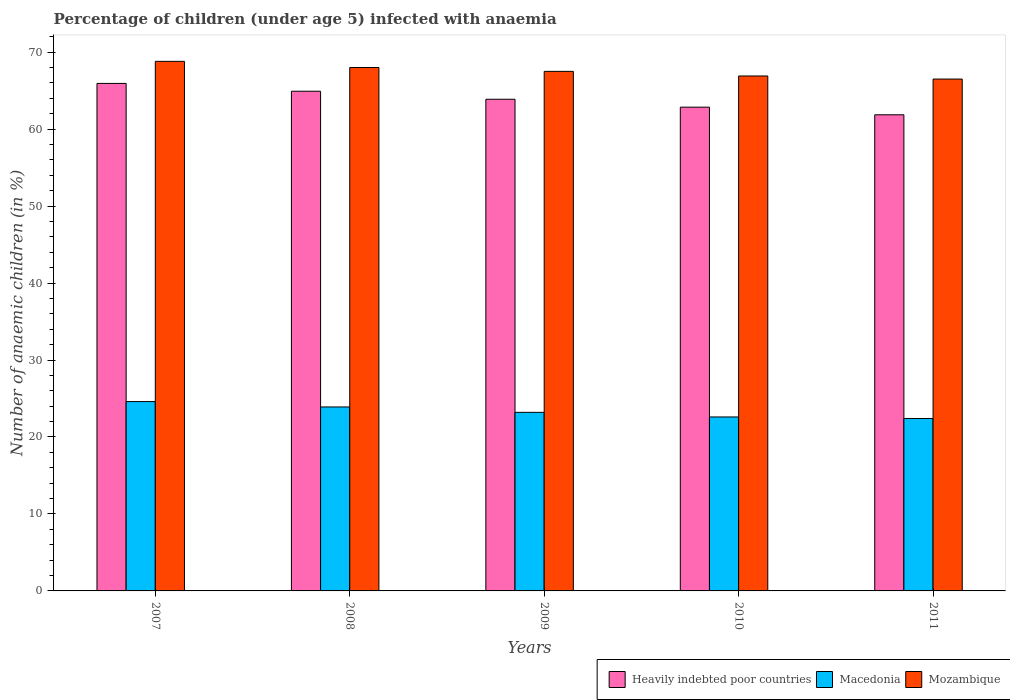How many different coloured bars are there?
Your answer should be very brief. 3. Are the number of bars per tick equal to the number of legend labels?
Give a very brief answer. Yes. How many bars are there on the 1st tick from the left?
Your answer should be very brief. 3. What is the percentage of children infected with anaemia in in Macedonia in 2010?
Offer a very short reply. 22.6. Across all years, what is the maximum percentage of children infected with anaemia in in Macedonia?
Offer a terse response. 24.6. Across all years, what is the minimum percentage of children infected with anaemia in in Mozambique?
Your answer should be very brief. 66.5. In which year was the percentage of children infected with anaemia in in Mozambique maximum?
Provide a succinct answer. 2007. In which year was the percentage of children infected with anaemia in in Macedonia minimum?
Offer a terse response. 2011. What is the total percentage of children infected with anaemia in in Macedonia in the graph?
Provide a succinct answer. 116.7. What is the difference between the percentage of children infected with anaemia in in Heavily indebted poor countries in 2007 and that in 2010?
Give a very brief answer. 3.09. What is the difference between the percentage of children infected with anaemia in in Mozambique in 2008 and the percentage of children infected with anaemia in in Macedonia in 2010?
Offer a terse response. 45.4. What is the average percentage of children infected with anaemia in in Mozambique per year?
Your answer should be very brief. 67.54. In the year 2009, what is the difference between the percentage of children infected with anaemia in in Heavily indebted poor countries and percentage of children infected with anaemia in in Mozambique?
Make the answer very short. -3.62. In how many years, is the percentage of children infected with anaemia in in Heavily indebted poor countries greater than 60 %?
Your answer should be very brief. 5. What is the ratio of the percentage of children infected with anaemia in in Macedonia in 2008 to that in 2011?
Your answer should be compact. 1.07. Is the percentage of children infected with anaemia in in Mozambique in 2009 less than that in 2010?
Give a very brief answer. No. Is the difference between the percentage of children infected with anaemia in in Heavily indebted poor countries in 2008 and 2011 greater than the difference between the percentage of children infected with anaemia in in Mozambique in 2008 and 2011?
Provide a succinct answer. Yes. What is the difference between the highest and the second highest percentage of children infected with anaemia in in Heavily indebted poor countries?
Ensure brevity in your answer.  1.02. What is the difference between the highest and the lowest percentage of children infected with anaemia in in Heavily indebted poor countries?
Provide a succinct answer. 4.08. In how many years, is the percentage of children infected with anaemia in in Macedonia greater than the average percentage of children infected with anaemia in in Macedonia taken over all years?
Provide a short and direct response. 2. Is the sum of the percentage of children infected with anaemia in in Heavily indebted poor countries in 2007 and 2010 greater than the maximum percentage of children infected with anaemia in in Mozambique across all years?
Offer a terse response. Yes. What does the 2nd bar from the left in 2011 represents?
Offer a very short reply. Macedonia. What does the 2nd bar from the right in 2008 represents?
Offer a terse response. Macedonia. What is the difference between two consecutive major ticks on the Y-axis?
Offer a very short reply. 10. Does the graph contain any zero values?
Your answer should be very brief. No. Where does the legend appear in the graph?
Your answer should be compact. Bottom right. What is the title of the graph?
Make the answer very short. Percentage of children (under age 5) infected with anaemia. Does "Bosnia and Herzegovina" appear as one of the legend labels in the graph?
Ensure brevity in your answer.  No. What is the label or title of the Y-axis?
Offer a terse response. Number of anaemic children (in %). What is the Number of anaemic children (in %) of Heavily indebted poor countries in 2007?
Keep it short and to the point. 65.93. What is the Number of anaemic children (in %) in Macedonia in 2007?
Your answer should be very brief. 24.6. What is the Number of anaemic children (in %) of Mozambique in 2007?
Provide a succinct answer. 68.8. What is the Number of anaemic children (in %) of Heavily indebted poor countries in 2008?
Offer a terse response. 64.92. What is the Number of anaemic children (in %) in Macedonia in 2008?
Your response must be concise. 23.9. What is the Number of anaemic children (in %) in Mozambique in 2008?
Offer a terse response. 68. What is the Number of anaemic children (in %) in Heavily indebted poor countries in 2009?
Provide a succinct answer. 63.88. What is the Number of anaemic children (in %) in Macedonia in 2009?
Your answer should be compact. 23.2. What is the Number of anaemic children (in %) of Mozambique in 2009?
Ensure brevity in your answer.  67.5. What is the Number of anaemic children (in %) in Heavily indebted poor countries in 2010?
Ensure brevity in your answer.  62.85. What is the Number of anaemic children (in %) in Macedonia in 2010?
Ensure brevity in your answer.  22.6. What is the Number of anaemic children (in %) of Mozambique in 2010?
Make the answer very short. 66.9. What is the Number of anaemic children (in %) in Heavily indebted poor countries in 2011?
Provide a succinct answer. 61.86. What is the Number of anaemic children (in %) in Macedonia in 2011?
Make the answer very short. 22.4. What is the Number of anaemic children (in %) in Mozambique in 2011?
Ensure brevity in your answer.  66.5. Across all years, what is the maximum Number of anaemic children (in %) of Heavily indebted poor countries?
Keep it short and to the point. 65.93. Across all years, what is the maximum Number of anaemic children (in %) of Macedonia?
Give a very brief answer. 24.6. Across all years, what is the maximum Number of anaemic children (in %) in Mozambique?
Give a very brief answer. 68.8. Across all years, what is the minimum Number of anaemic children (in %) in Heavily indebted poor countries?
Your response must be concise. 61.86. Across all years, what is the minimum Number of anaemic children (in %) of Macedonia?
Make the answer very short. 22.4. Across all years, what is the minimum Number of anaemic children (in %) in Mozambique?
Your answer should be compact. 66.5. What is the total Number of anaemic children (in %) in Heavily indebted poor countries in the graph?
Provide a short and direct response. 319.43. What is the total Number of anaemic children (in %) of Macedonia in the graph?
Your answer should be very brief. 116.7. What is the total Number of anaemic children (in %) in Mozambique in the graph?
Provide a succinct answer. 337.7. What is the difference between the Number of anaemic children (in %) of Heavily indebted poor countries in 2007 and that in 2008?
Your answer should be compact. 1.02. What is the difference between the Number of anaemic children (in %) of Macedonia in 2007 and that in 2008?
Provide a short and direct response. 0.7. What is the difference between the Number of anaemic children (in %) of Heavily indebted poor countries in 2007 and that in 2009?
Offer a very short reply. 2.06. What is the difference between the Number of anaemic children (in %) in Macedonia in 2007 and that in 2009?
Make the answer very short. 1.4. What is the difference between the Number of anaemic children (in %) in Mozambique in 2007 and that in 2009?
Give a very brief answer. 1.3. What is the difference between the Number of anaemic children (in %) in Heavily indebted poor countries in 2007 and that in 2010?
Your answer should be very brief. 3.09. What is the difference between the Number of anaemic children (in %) in Heavily indebted poor countries in 2007 and that in 2011?
Ensure brevity in your answer.  4.08. What is the difference between the Number of anaemic children (in %) of Mozambique in 2007 and that in 2011?
Provide a short and direct response. 2.3. What is the difference between the Number of anaemic children (in %) of Heavily indebted poor countries in 2008 and that in 2009?
Keep it short and to the point. 1.04. What is the difference between the Number of anaemic children (in %) of Macedonia in 2008 and that in 2009?
Make the answer very short. 0.7. What is the difference between the Number of anaemic children (in %) of Heavily indebted poor countries in 2008 and that in 2010?
Make the answer very short. 2.07. What is the difference between the Number of anaemic children (in %) in Macedonia in 2008 and that in 2010?
Make the answer very short. 1.3. What is the difference between the Number of anaemic children (in %) in Mozambique in 2008 and that in 2010?
Give a very brief answer. 1.1. What is the difference between the Number of anaemic children (in %) in Heavily indebted poor countries in 2008 and that in 2011?
Provide a short and direct response. 3.06. What is the difference between the Number of anaemic children (in %) of Macedonia in 2008 and that in 2011?
Offer a very short reply. 1.5. What is the difference between the Number of anaemic children (in %) of Heavily indebted poor countries in 2009 and that in 2010?
Your response must be concise. 1.03. What is the difference between the Number of anaemic children (in %) in Heavily indebted poor countries in 2009 and that in 2011?
Provide a succinct answer. 2.02. What is the difference between the Number of anaemic children (in %) of Macedonia in 2009 and that in 2011?
Your answer should be compact. 0.8. What is the difference between the Number of anaemic children (in %) of Heavily indebted poor countries in 2010 and that in 2011?
Your response must be concise. 0.99. What is the difference between the Number of anaemic children (in %) in Heavily indebted poor countries in 2007 and the Number of anaemic children (in %) in Macedonia in 2008?
Give a very brief answer. 42.03. What is the difference between the Number of anaemic children (in %) of Heavily indebted poor countries in 2007 and the Number of anaemic children (in %) of Mozambique in 2008?
Provide a short and direct response. -2.07. What is the difference between the Number of anaemic children (in %) of Macedonia in 2007 and the Number of anaemic children (in %) of Mozambique in 2008?
Offer a very short reply. -43.4. What is the difference between the Number of anaemic children (in %) of Heavily indebted poor countries in 2007 and the Number of anaemic children (in %) of Macedonia in 2009?
Keep it short and to the point. 42.73. What is the difference between the Number of anaemic children (in %) in Heavily indebted poor countries in 2007 and the Number of anaemic children (in %) in Mozambique in 2009?
Keep it short and to the point. -1.57. What is the difference between the Number of anaemic children (in %) in Macedonia in 2007 and the Number of anaemic children (in %) in Mozambique in 2009?
Your answer should be very brief. -42.9. What is the difference between the Number of anaemic children (in %) in Heavily indebted poor countries in 2007 and the Number of anaemic children (in %) in Macedonia in 2010?
Your answer should be compact. 43.33. What is the difference between the Number of anaemic children (in %) in Heavily indebted poor countries in 2007 and the Number of anaemic children (in %) in Mozambique in 2010?
Give a very brief answer. -0.97. What is the difference between the Number of anaemic children (in %) of Macedonia in 2007 and the Number of anaemic children (in %) of Mozambique in 2010?
Keep it short and to the point. -42.3. What is the difference between the Number of anaemic children (in %) of Heavily indebted poor countries in 2007 and the Number of anaemic children (in %) of Macedonia in 2011?
Your response must be concise. 43.53. What is the difference between the Number of anaemic children (in %) of Heavily indebted poor countries in 2007 and the Number of anaemic children (in %) of Mozambique in 2011?
Your response must be concise. -0.57. What is the difference between the Number of anaemic children (in %) of Macedonia in 2007 and the Number of anaemic children (in %) of Mozambique in 2011?
Keep it short and to the point. -41.9. What is the difference between the Number of anaemic children (in %) of Heavily indebted poor countries in 2008 and the Number of anaemic children (in %) of Macedonia in 2009?
Offer a very short reply. 41.72. What is the difference between the Number of anaemic children (in %) in Heavily indebted poor countries in 2008 and the Number of anaemic children (in %) in Mozambique in 2009?
Keep it short and to the point. -2.58. What is the difference between the Number of anaemic children (in %) in Macedonia in 2008 and the Number of anaemic children (in %) in Mozambique in 2009?
Make the answer very short. -43.6. What is the difference between the Number of anaemic children (in %) in Heavily indebted poor countries in 2008 and the Number of anaemic children (in %) in Macedonia in 2010?
Your response must be concise. 42.32. What is the difference between the Number of anaemic children (in %) in Heavily indebted poor countries in 2008 and the Number of anaemic children (in %) in Mozambique in 2010?
Offer a very short reply. -1.98. What is the difference between the Number of anaemic children (in %) of Macedonia in 2008 and the Number of anaemic children (in %) of Mozambique in 2010?
Provide a succinct answer. -43. What is the difference between the Number of anaemic children (in %) of Heavily indebted poor countries in 2008 and the Number of anaemic children (in %) of Macedonia in 2011?
Offer a terse response. 42.52. What is the difference between the Number of anaemic children (in %) of Heavily indebted poor countries in 2008 and the Number of anaemic children (in %) of Mozambique in 2011?
Your answer should be very brief. -1.58. What is the difference between the Number of anaemic children (in %) of Macedonia in 2008 and the Number of anaemic children (in %) of Mozambique in 2011?
Ensure brevity in your answer.  -42.6. What is the difference between the Number of anaemic children (in %) of Heavily indebted poor countries in 2009 and the Number of anaemic children (in %) of Macedonia in 2010?
Your answer should be compact. 41.28. What is the difference between the Number of anaemic children (in %) in Heavily indebted poor countries in 2009 and the Number of anaemic children (in %) in Mozambique in 2010?
Your response must be concise. -3.02. What is the difference between the Number of anaemic children (in %) of Macedonia in 2009 and the Number of anaemic children (in %) of Mozambique in 2010?
Provide a succinct answer. -43.7. What is the difference between the Number of anaemic children (in %) in Heavily indebted poor countries in 2009 and the Number of anaemic children (in %) in Macedonia in 2011?
Your answer should be compact. 41.48. What is the difference between the Number of anaemic children (in %) of Heavily indebted poor countries in 2009 and the Number of anaemic children (in %) of Mozambique in 2011?
Provide a short and direct response. -2.62. What is the difference between the Number of anaemic children (in %) in Macedonia in 2009 and the Number of anaemic children (in %) in Mozambique in 2011?
Offer a terse response. -43.3. What is the difference between the Number of anaemic children (in %) of Heavily indebted poor countries in 2010 and the Number of anaemic children (in %) of Macedonia in 2011?
Offer a terse response. 40.45. What is the difference between the Number of anaemic children (in %) in Heavily indebted poor countries in 2010 and the Number of anaemic children (in %) in Mozambique in 2011?
Make the answer very short. -3.65. What is the difference between the Number of anaemic children (in %) of Macedonia in 2010 and the Number of anaemic children (in %) of Mozambique in 2011?
Provide a succinct answer. -43.9. What is the average Number of anaemic children (in %) in Heavily indebted poor countries per year?
Offer a very short reply. 63.89. What is the average Number of anaemic children (in %) of Macedonia per year?
Your response must be concise. 23.34. What is the average Number of anaemic children (in %) of Mozambique per year?
Your answer should be compact. 67.54. In the year 2007, what is the difference between the Number of anaemic children (in %) of Heavily indebted poor countries and Number of anaemic children (in %) of Macedonia?
Ensure brevity in your answer.  41.33. In the year 2007, what is the difference between the Number of anaemic children (in %) in Heavily indebted poor countries and Number of anaemic children (in %) in Mozambique?
Make the answer very short. -2.87. In the year 2007, what is the difference between the Number of anaemic children (in %) in Macedonia and Number of anaemic children (in %) in Mozambique?
Make the answer very short. -44.2. In the year 2008, what is the difference between the Number of anaemic children (in %) in Heavily indebted poor countries and Number of anaemic children (in %) in Macedonia?
Your answer should be very brief. 41.02. In the year 2008, what is the difference between the Number of anaemic children (in %) of Heavily indebted poor countries and Number of anaemic children (in %) of Mozambique?
Make the answer very short. -3.08. In the year 2008, what is the difference between the Number of anaemic children (in %) of Macedonia and Number of anaemic children (in %) of Mozambique?
Your answer should be very brief. -44.1. In the year 2009, what is the difference between the Number of anaemic children (in %) in Heavily indebted poor countries and Number of anaemic children (in %) in Macedonia?
Ensure brevity in your answer.  40.68. In the year 2009, what is the difference between the Number of anaemic children (in %) in Heavily indebted poor countries and Number of anaemic children (in %) in Mozambique?
Provide a short and direct response. -3.62. In the year 2009, what is the difference between the Number of anaemic children (in %) in Macedonia and Number of anaemic children (in %) in Mozambique?
Your response must be concise. -44.3. In the year 2010, what is the difference between the Number of anaemic children (in %) in Heavily indebted poor countries and Number of anaemic children (in %) in Macedonia?
Offer a terse response. 40.25. In the year 2010, what is the difference between the Number of anaemic children (in %) in Heavily indebted poor countries and Number of anaemic children (in %) in Mozambique?
Your answer should be very brief. -4.05. In the year 2010, what is the difference between the Number of anaemic children (in %) of Macedonia and Number of anaemic children (in %) of Mozambique?
Keep it short and to the point. -44.3. In the year 2011, what is the difference between the Number of anaemic children (in %) of Heavily indebted poor countries and Number of anaemic children (in %) of Macedonia?
Give a very brief answer. 39.46. In the year 2011, what is the difference between the Number of anaemic children (in %) of Heavily indebted poor countries and Number of anaemic children (in %) of Mozambique?
Provide a short and direct response. -4.64. In the year 2011, what is the difference between the Number of anaemic children (in %) of Macedonia and Number of anaemic children (in %) of Mozambique?
Your response must be concise. -44.1. What is the ratio of the Number of anaemic children (in %) of Heavily indebted poor countries in 2007 to that in 2008?
Make the answer very short. 1.02. What is the ratio of the Number of anaemic children (in %) of Macedonia in 2007 to that in 2008?
Ensure brevity in your answer.  1.03. What is the ratio of the Number of anaemic children (in %) of Mozambique in 2007 to that in 2008?
Make the answer very short. 1.01. What is the ratio of the Number of anaemic children (in %) in Heavily indebted poor countries in 2007 to that in 2009?
Provide a succinct answer. 1.03. What is the ratio of the Number of anaemic children (in %) in Macedonia in 2007 to that in 2009?
Your answer should be compact. 1.06. What is the ratio of the Number of anaemic children (in %) in Mozambique in 2007 to that in 2009?
Make the answer very short. 1.02. What is the ratio of the Number of anaemic children (in %) of Heavily indebted poor countries in 2007 to that in 2010?
Provide a succinct answer. 1.05. What is the ratio of the Number of anaemic children (in %) of Macedonia in 2007 to that in 2010?
Offer a terse response. 1.09. What is the ratio of the Number of anaemic children (in %) of Mozambique in 2007 to that in 2010?
Your answer should be very brief. 1.03. What is the ratio of the Number of anaemic children (in %) in Heavily indebted poor countries in 2007 to that in 2011?
Ensure brevity in your answer.  1.07. What is the ratio of the Number of anaemic children (in %) in Macedonia in 2007 to that in 2011?
Provide a short and direct response. 1.1. What is the ratio of the Number of anaemic children (in %) in Mozambique in 2007 to that in 2011?
Your response must be concise. 1.03. What is the ratio of the Number of anaemic children (in %) in Heavily indebted poor countries in 2008 to that in 2009?
Your answer should be compact. 1.02. What is the ratio of the Number of anaemic children (in %) in Macedonia in 2008 to that in 2009?
Give a very brief answer. 1.03. What is the ratio of the Number of anaemic children (in %) of Mozambique in 2008 to that in 2009?
Your answer should be very brief. 1.01. What is the ratio of the Number of anaemic children (in %) in Heavily indebted poor countries in 2008 to that in 2010?
Provide a short and direct response. 1.03. What is the ratio of the Number of anaemic children (in %) of Macedonia in 2008 to that in 2010?
Give a very brief answer. 1.06. What is the ratio of the Number of anaemic children (in %) in Mozambique in 2008 to that in 2010?
Your response must be concise. 1.02. What is the ratio of the Number of anaemic children (in %) of Heavily indebted poor countries in 2008 to that in 2011?
Give a very brief answer. 1.05. What is the ratio of the Number of anaemic children (in %) in Macedonia in 2008 to that in 2011?
Ensure brevity in your answer.  1.07. What is the ratio of the Number of anaemic children (in %) in Mozambique in 2008 to that in 2011?
Provide a short and direct response. 1.02. What is the ratio of the Number of anaemic children (in %) in Heavily indebted poor countries in 2009 to that in 2010?
Your response must be concise. 1.02. What is the ratio of the Number of anaemic children (in %) in Macedonia in 2009 to that in 2010?
Keep it short and to the point. 1.03. What is the ratio of the Number of anaemic children (in %) of Heavily indebted poor countries in 2009 to that in 2011?
Your response must be concise. 1.03. What is the ratio of the Number of anaemic children (in %) of Macedonia in 2009 to that in 2011?
Your response must be concise. 1.04. What is the ratio of the Number of anaemic children (in %) of Mozambique in 2009 to that in 2011?
Ensure brevity in your answer.  1.01. What is the ratio of the Number of anaemic children (in %) of Macedonia in 2010 to that in 2011?
Offer a very short reply. 1.01. What is the ratio of the Number of anaemic children (in %) in Mozambique in 2010 to that in 2011?
Make the answer very short. 1.01. What is the difference between the highest and the second highest Number of anaemic children (in %) in Heavily indebted poor countries?
Your answer should be very brief. 1.02. What is the difference between the highest and the second highest Number of anaemic children (in %) in Macedonia?
Your response must be concise. 0.7. What is the difference between the highest and the lowest Number of anaemic children (in %) in Heavily indebted poor countries?
Ensure brevity in your answer.  4.08. What is the difference between the highest and the lowest Number of anaemic children (in %) in Mozambique?
Make the answer very short. 2.3. 